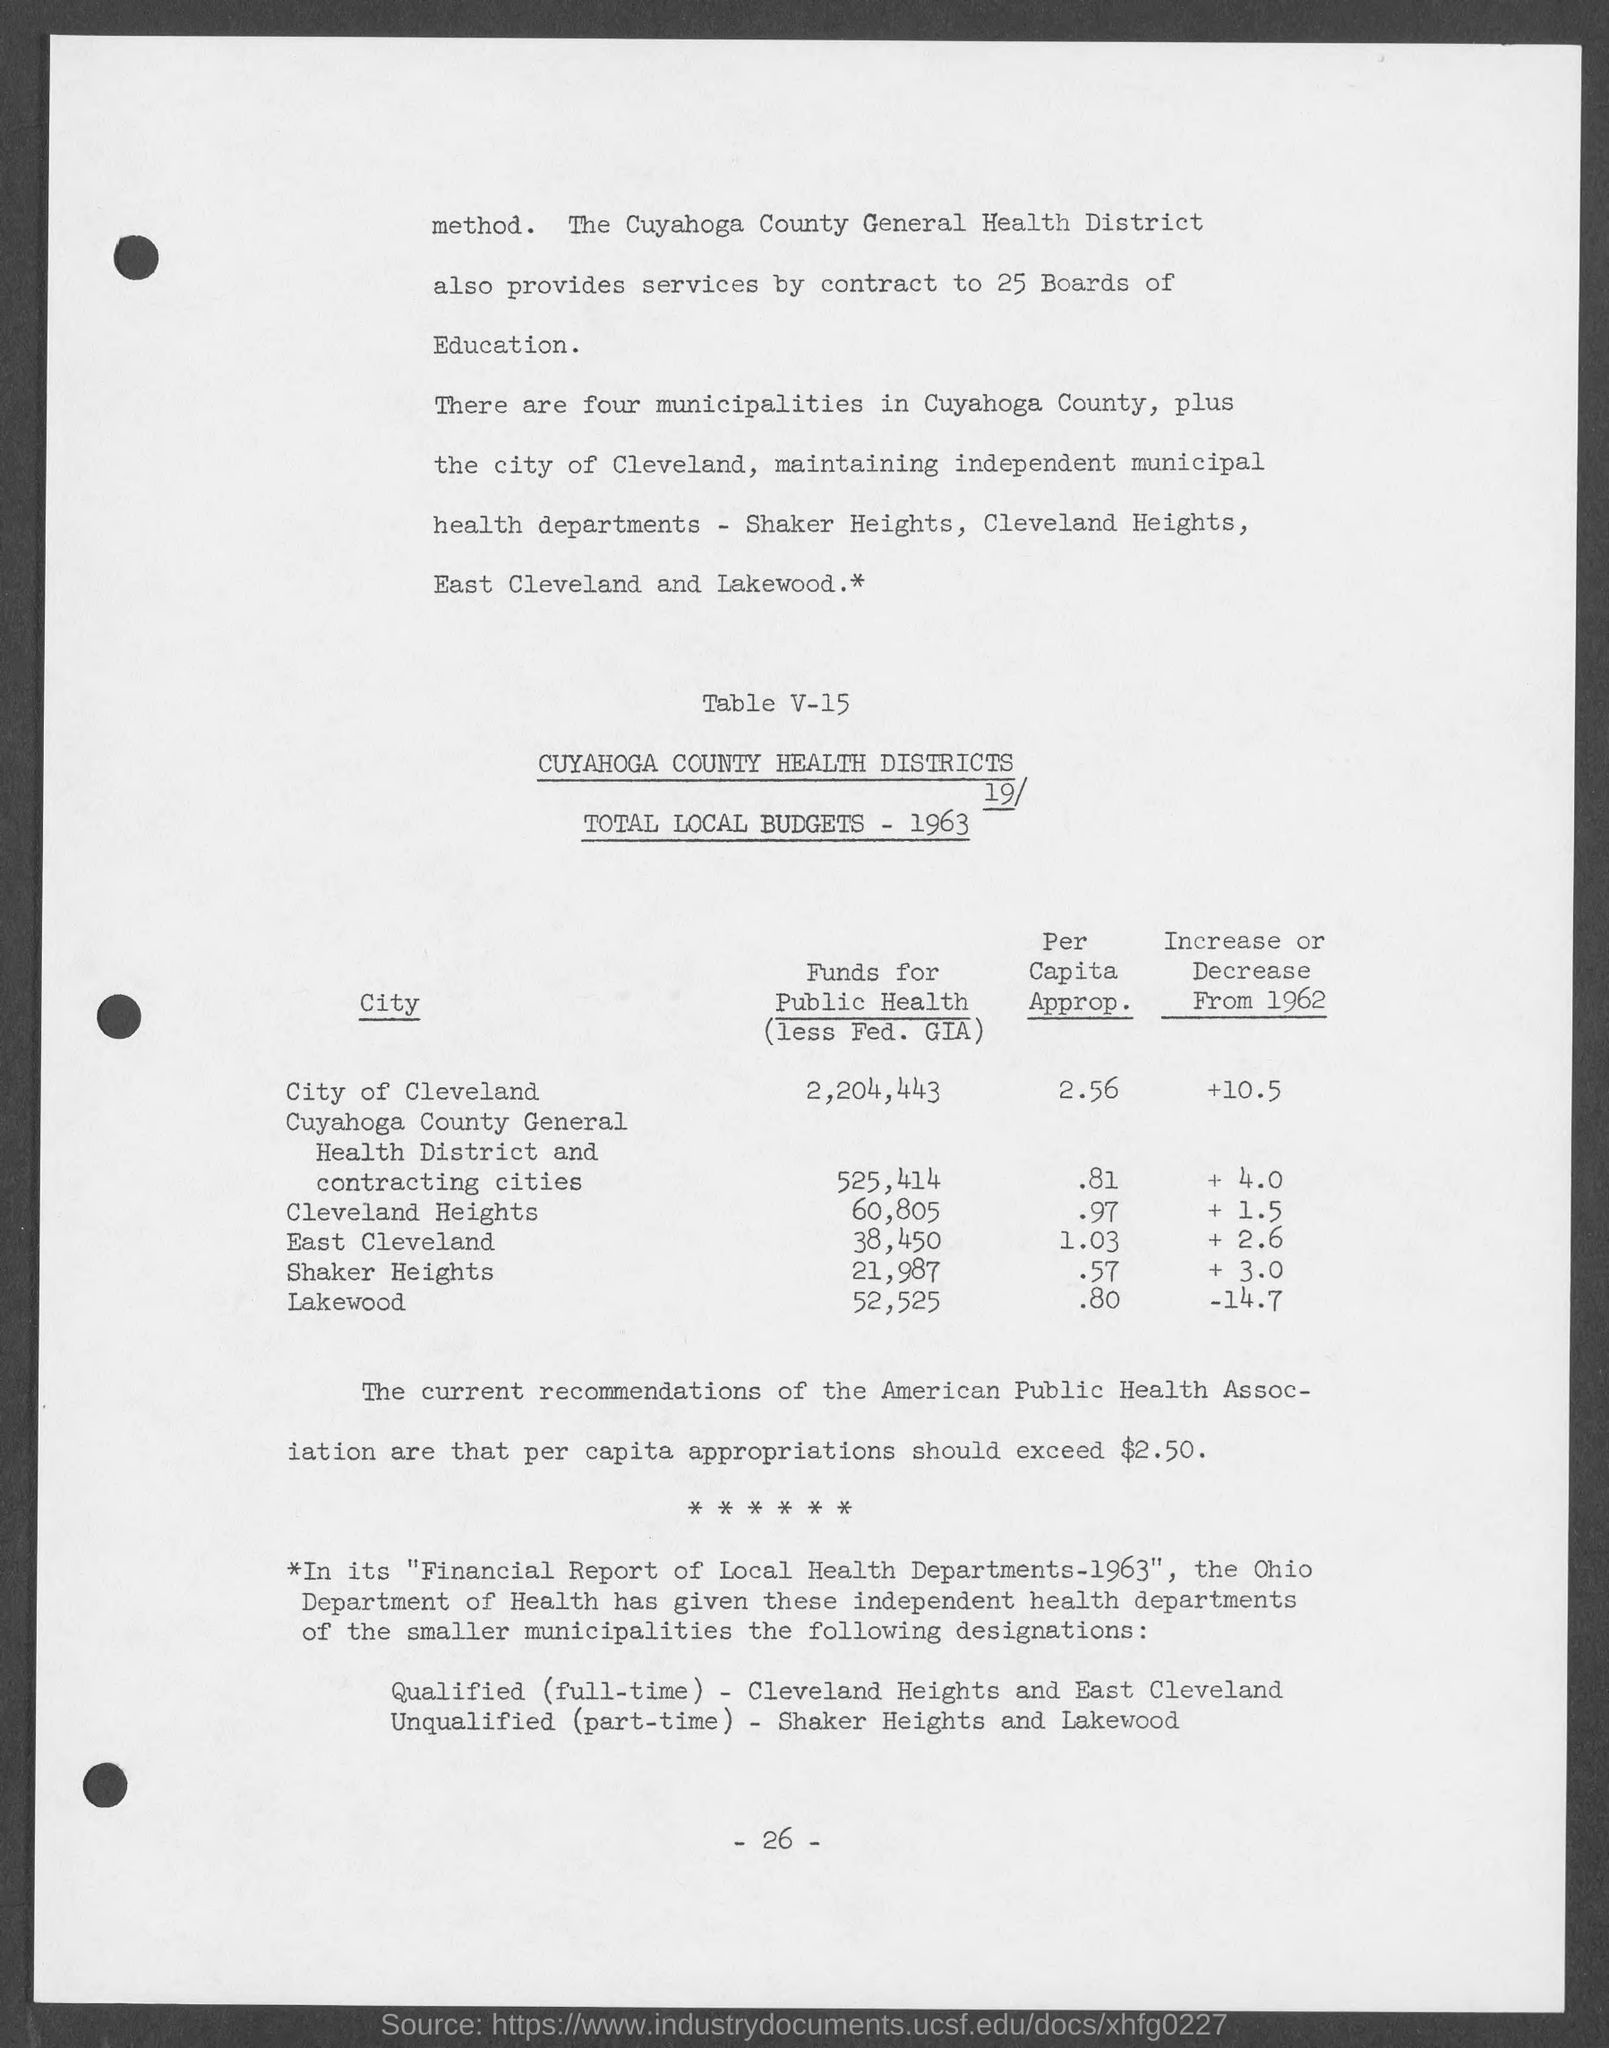Point out several critical features in this image. The Ohio Department of Health has designated independent health departments for smaller municipalities. Approximately $2.56 is the per capita allocation for the city of Cleveland. The funds allocated for public health in Lakewood are $52,525. Four municipalities exist in Cuyahoga county. The Cuyahoga County General Health District provides service to 25 boards of education. 